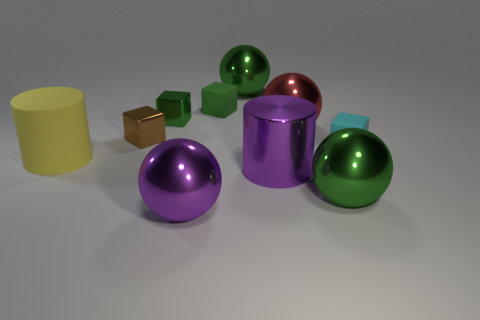What textures can be observed on the objects and which one seems to be different? Most objects in the image have a smooth and reflective texture, indicative of a polished metallic or plastic surface. The yellow cylinder, however, has a matte, non-reflective surface which makes it stand out from the others. 